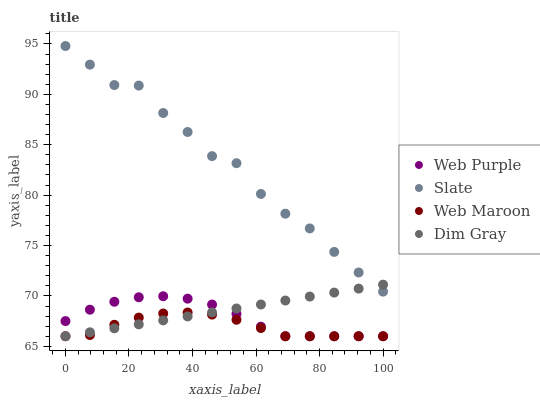Does Web Maroon have the minimum area under the curve?
Answer yes or no. Yes. Does Slate have the maximum area under the curve?
Answer yes or no. Yes. Does Dim Gray have the minimum area under the curve?
Answer yes or no. No. Does Dim Gray have the maximum area under the curve?
Answer yes or no. No. Is Dim Gray the smoothest?
Answer yes or no. Yes. Is Slate the roughest?
Answer yes or no. Yes. Is Web Maroon the smoothest?
Answer yes or no. No. Is Web Maroon the roughest?
Answer yes or no. No. Does Web Purple have the lowest value?
Answer yes or no. Yes. Does Slate have the lowest value?
Answer yes or no. No. Does Slate have the highest value?
Answer yes or no. Yes. Does Dim Gray have the highest value?
Answer yes or no. No. Is Web Purple less than Slate?
Answer yes or no. Yes. Is Slate greater than Web Maroon?
Answer yes or no. Yes. Does Web Purple intersect Dim Gray?
Answer yes or no. Yes. Is Web Purple less than Dim Gray?
Answer yes or no. No. Is Web Purple greater than Dim Gray?
Answer yes or no. No. Does Web Purple intersect Slate?
Answer yes or no. No. 